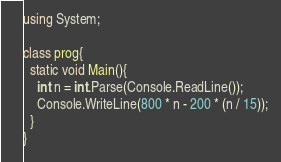<code> <loc_0><loc_0><loc_500><loc_500><_C#_>using System;

class prog{
  static void Main(){
    int n = int.Parse(Console.ReadLine());
    Console.WriteLine(800 * n - 200 * (n / 15));
  }
}</code> 